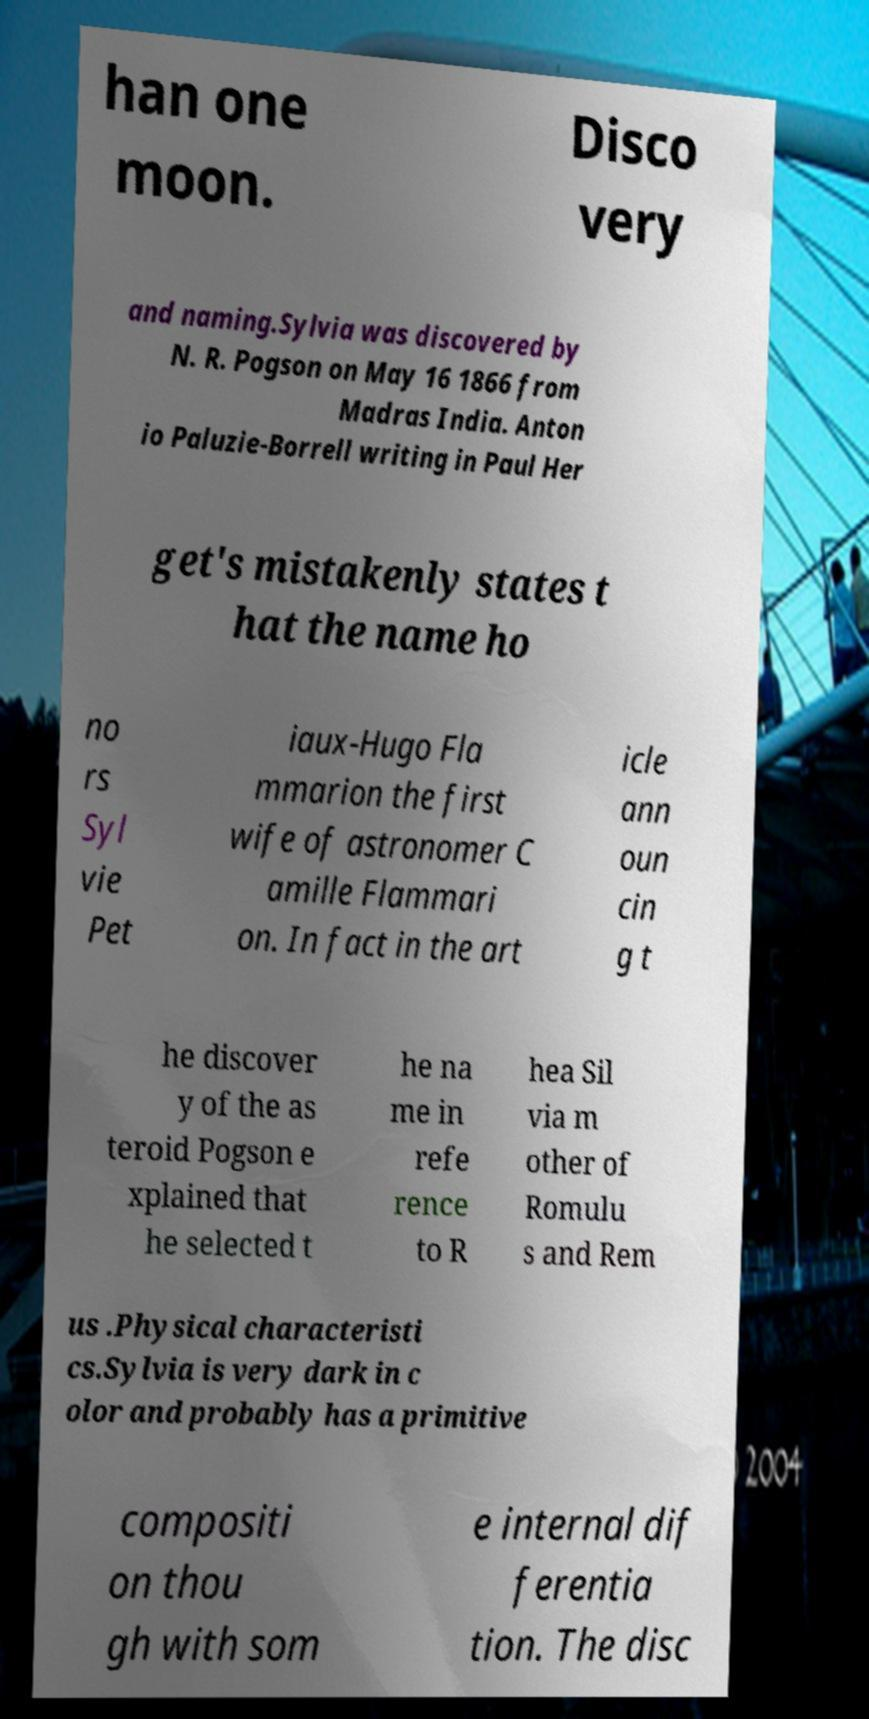Please read and relay the text visible in this image. What does it say? han one moon. Disco very and naming.Sylvia was discovered by N. R. Pogson on May 16 1866 from Madras India. Anton io Paluzie-Borrell writing in Paul Her get's mistakenly states t hat the name ho no rs Syl vie Pet iaux-Hugo Fla mmarion the first wife of astronomer C amille Flammari on. In fact in the art icle ann oun cin g t he discover y of the as teroid Pogson e xplained that he selected t he na me in refe rence to R hea Sil via m other of Romulu s and Rem us .Physical characteristi cs.Sylvia is very dark in c olor and probably has a primitive compositi on thou gh with som e internal dif ferentia tion. The disc 